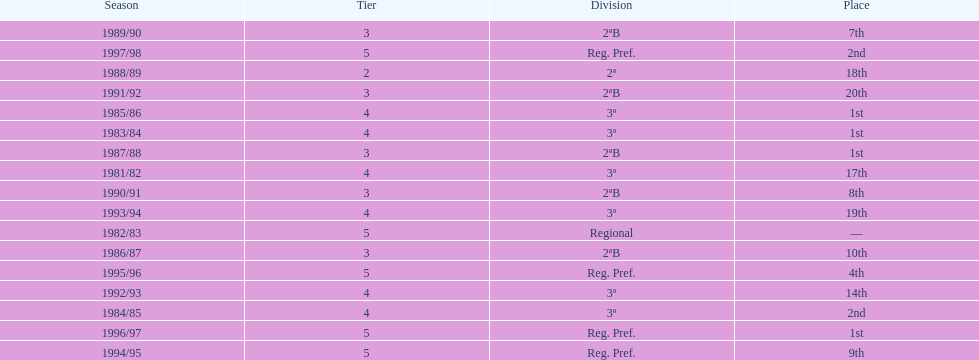How many seasons are shown in this chart? 17. 